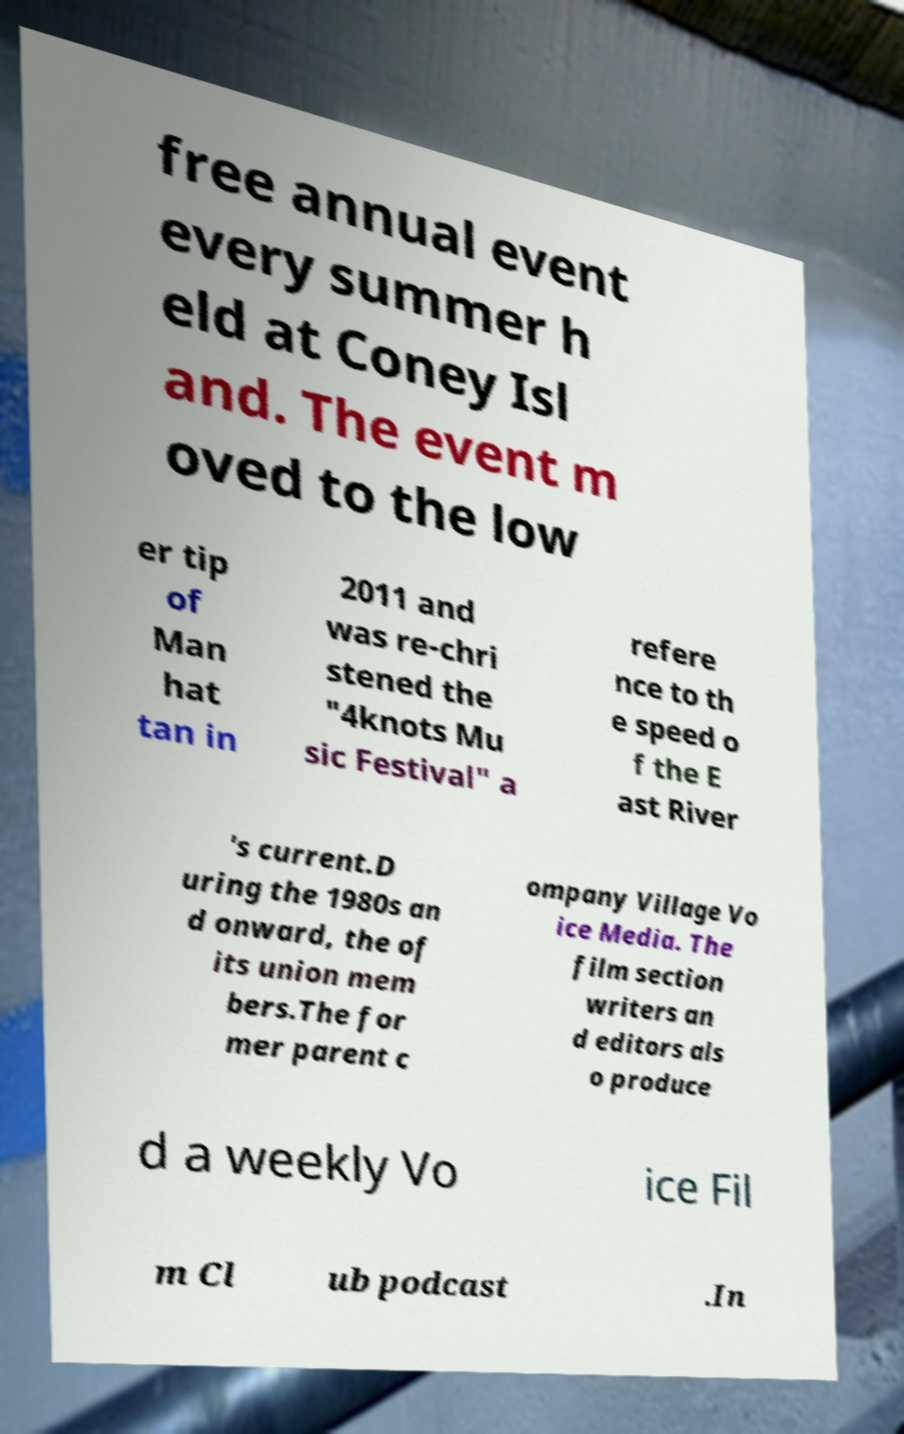I need the written content from this picture converted into text. Can you do that? free annual event every summer h eld at Coney Isl and. The event m oved to the low er tip of Man hat tan in 2011 and was re-chri stened the "4knots Mu sic Festival" a refere nce to th e speed o f the E ast River 's current.D uring the 1980s an d onward, the of its union mem bers.The for mer parent c ompany Village Vo ice Media. The film section writers an d editors als o produce d a weekly Vo ice Fil m Cl ub podcast .In 